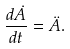<formula> <loc_0><loc_0><loc_500><loc_500>\frac { d \dot { A } } { d t } = \ddot { A } .</formula> 